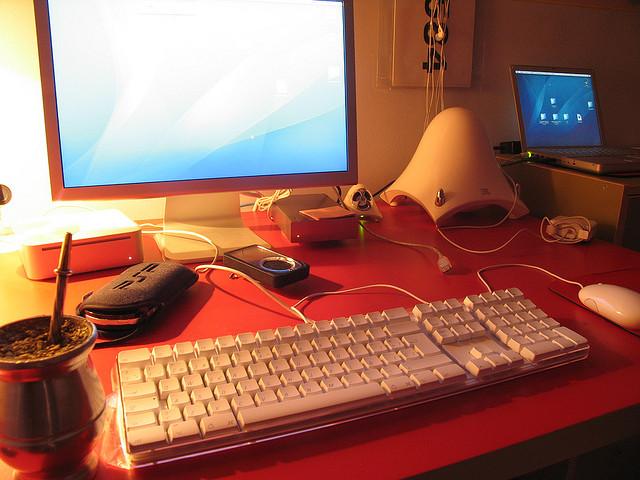What is to the left of the keyboard?
Give a very brief answer. Food. Is this at night?
Short answer required. Yes. How many electronic devices are in the picture?
Keep it brief. 5. 